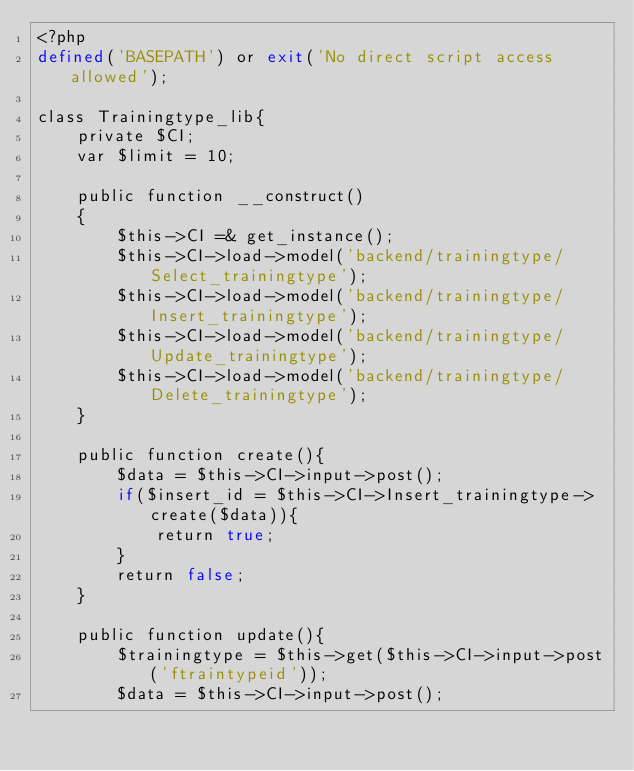<code> <loc_0><loc_0><loc_500><loc_500><_PHP_><?php
defined('BASEPATH') or exit('No direct script access allowed');

class Trainingtype_lib{
    private $CI;
    var $limit = 10;

    public function __construct()
    {
        $this->CI =& get_instance();
        $this->CI->load->model('backend/trainingtype/Select_trainingtype');
        $this->CI->load->model('backend/trainingtype/Insert_trainingtype');
        $this->CI->load->model('backend/trainingtype/Update_trainingtype');
        $this->CI->load->model('backend/trainingtype/Delete_trainingtype');
    }

    public function create(){
        $data = $this->CI->input->post();
        if($insert_id = $this->CI->Insert_trainingtype->create($data)){
            return true;
        }
        return false;
    }

    public function update(){
        $trainingtype = $this->get($this->CI->input->post('ftraintypeid'));
        $data = $this->CI->input->post();
</code> 